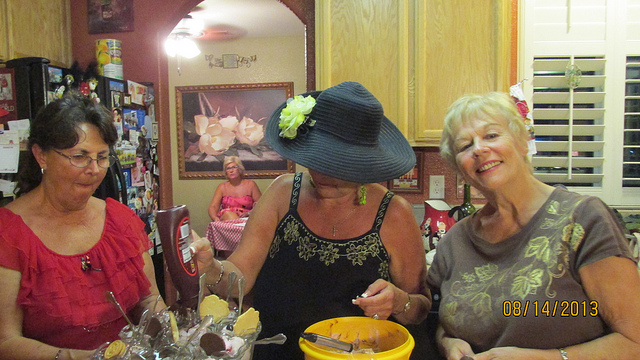Extract all visible text content from this image. 08/14/2013 